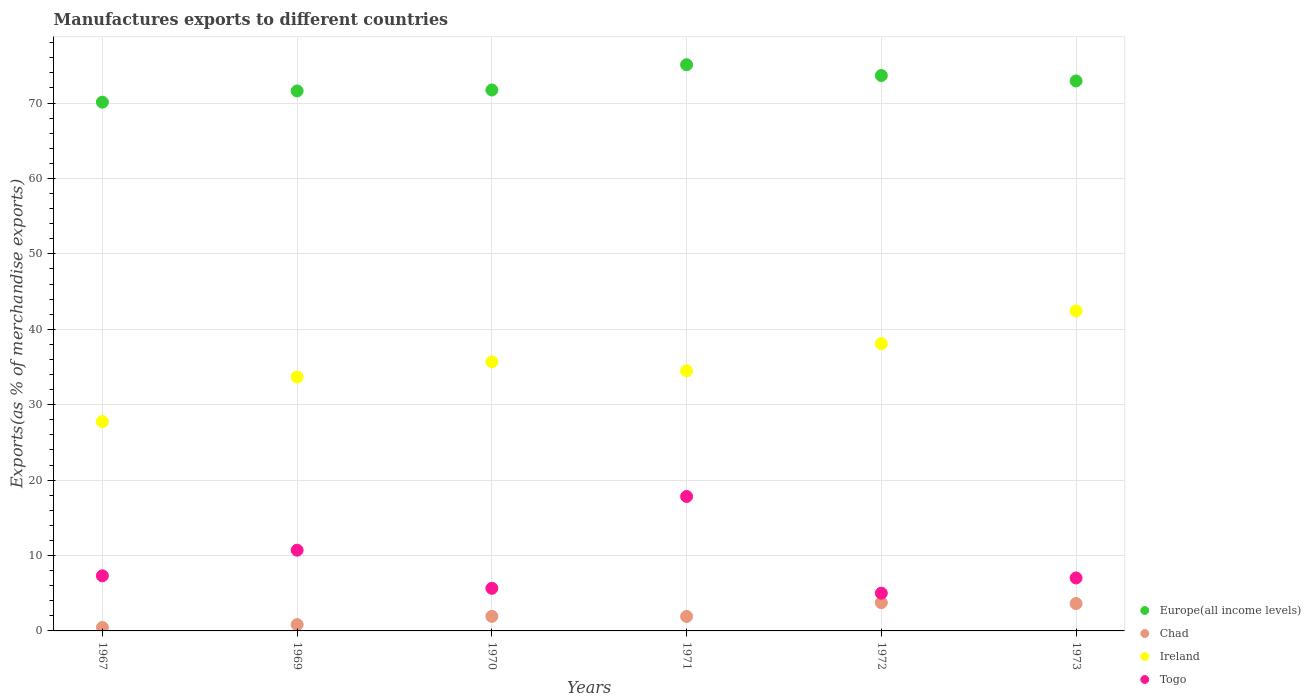Is the number of dotlines equal to the number of legend labels?
Your answer should be compact. Yes. What is the percentage of exports to different countries in Togo in 1973?
Provide a short and direct response. 7.02. Across all years, what is the maximum percentage of exports to different countries in Togo?
Your answer should be very brief. 17.83. Across all years, what is the minimum percentage of exports to different countries in Togo?
Ensure brevity in your answer.  5.01. In which year was the percentage of exports to different countries in Europe(all income levels) maximum?
Make the answer very short. 1971. What is the total percentage of exports to different countries in Ireland in the graph?
Your answer should be compact. 212.14. What is the difference between the percentage of exports to different countries in Chad in 1969 and that in 1972?
Your response must be concise. -2.91. What is the difference between the percentage of exports to different countries in Ireland in 1967 and the percentage of exports to different countries in Europe(all income levels) in 1970?
Your answer should be compact. -43.96. What is the average percentage of exports to different countries in Chad per year?
Keep it short and to the point. 2.09. In the year 1970, what is the difference between the percentage of exports to different countries in Europe(all income levels) and percentage of exports to different countries in Togo?
Keep it short and to the point. 66.08. What is the ratio of the percentage of exports to different countries in Europe(all income levels) in 1967 to that in 1972?
Your answer should be very brief. 0.95. What is the difference between the highest and the second highest percentage of exports to different countries in Ireland?
Keep it short and to the point. 4.33. What is the difference between the highest and the lowest percentage of exports to different countries in Europe(all income levels)?
Keep it short and to the point. 4.97. In how many years, is the percentage of exports to different countries in Togo greater than the average percentage of exports to different countries in Togo taken over all years?
Provide a succinct answer. 2. Is it the case that in every year, the sum of the percentage of exports to different countries in Togo and percentage of exports to different countries in Europe(all income levels)  is greater than the sum of percentage of exports to different countries in Chad and percentage of exports to different countries in Ireland?
Provide a short and direct response. Yes. Does the percentage of exports to different countries in Chad monotonically increase over the years?
Offer a very short reply. No. How many dotlines are there?
Offer a terse response. 4. What is the difference between two consecutive major ticks on the Y-axis?
Your answer should be compact. 10. Are the values on the major ticks of Y-axis written in scientific E-notation?
Make the answer very short. No. Where does the legend appear in the graph?
Provide a short and direct response. Bottom right. How many legend labels are there?
Make the answer very short. 4. What is the title of the graph?
Make the answer very short. Manufactures exports to different countries. What is the label or title of the Y-axis?
Make the answer very short. Exports(as % of merchandise exports). What is the Exports(as % of merchandise exports) in Europe(all income levels) in 1967?
Ensure brevity in your answer.  70.12. What is the Exports(as % of merchandise exports) in Chad in 1967?
Keep it short and to the point. 0.45. What is the Exports(as % of merchandise exports) of Ireland in 1967?
Offer a very short reply. 27.77. What is the Exports(as % of merchandise exports) in Togo in 1967?
Make the answer very short. 7.31. What is the Exports(as % of merchandise exports) of Europe(all income levels) in 1969?
Give a very brief answer. 71.6. What is the Exports(as % of merchandise exports) in Chad in 1969?
Ensure brevity in your answer.  0.84. What is the Exports(as % of merchandise exports) of Ireland in 1969?
Provide a succinct answer. 33.67. What is the Exports(as % of merchandise exports) of Togo in 1969?
Make the answer very short. 10.71. What is the Exports(as % of merchandise exports) in Europe(all income levels) in 1970?
Provide a succinct answer. 71.73. What is the Exports(as % of merchandise exports) in Chad in 1970?
Your answer should be compact. 1.93. What is the Exports(as % of merchandise exports) in Ireland in 1970?
Offer a terse response. 35.69. What is the Exports(as % of merchandise exports) in Togo in 1970?
Your response must be concise. 5.65. What is the Exports(as % of merchandise exports) of Europe(all income levels) in 1971?
Keep it short and to the point. 75.08. What is the Exports(as % of merchandise exports) of Chad in 1971?
Provide a short and direct response. 1.92. What is the Exports(as % of merchandise exports) in Ireland in 1971?
Offer a terse response. 34.49. What is the Exports(as % of merchandise exports) in Togo in 1971?
Provide a short and direct response. 17.83. What is the Exports(as % of merchandise exports) in Europe(all income levels) in 1972?
Provide a succinct answer. 73.65. What is the Exports(as % of merchandise exports) of Chad in 1972?
Make the answer very short. 3.75. What is the Exports(as % of merchandise exports) of Ireland in 1972?
Offer a terse response. 38.1. What is the Exports(as % of merchandise exports) in Togo in 1972?
Provide a short and direct response. 5.01. What is the Exports(as % of merchandise exports) of Europe(all income levels) in 1973?
Your response must be concise. 72.93. What is the Exports(as % of merchandise exports) in Chad in 1973?
Provide a succinct answer. 3.63. What is the Exports(as % of merchandise exports) of Ireland in 1973?
Make the answer very short. 42.43. What is the Exports(as % of merchandise exports) in Togo in 1973?
Keep it short and to the point. 7.02. Across all years, what is the maximum Exports(as % of merchandise exports) in Europe(all income levels)?
Provide a succinct answer. 75.08. Across all years, what is the maximum Exports(as % of merchandise exports) in Chad?
Offer a very short reply. 3.75. Across all years, what is the maximum Exports(as % of merchandise exports) of Ireland?
Your answer should be compact. 42.43. Across all years, what is the maximum Exports(as % of merchandise exports) in Togo?
Your answer should be compact. 17.83. Across all years, what is the minimum Exports(as % of merchandise exports) of Europe(all income levels)?
Your response must be concise. 70.12. Across all years, what is the minimum Exports(as % of merchandise exports) in Chad?
Keep it short and to the point. 0.45. Across all years, what is the minimum Exports(as % of merchandise exports) of Ireland?
Ensure brevity in your answer.  27.77. Across all years, what is the minimum Exports(as % of merchandise exports) of Togo?
Keep it short and to the point. 5.01. What is the total Exports(as % of merchandise exports) in Europe(all income levels) in the graph?
Provide a short and direct response. 435.11. What is the total Exports(as % of merchandise exports) of Chad in the graph?
Offer a very short reply. 12.52. What is the total Exports(as % of merchandise exports) in Ireland in the graph?
Keep it short and to the point. 212.14. What is the total Exports(as % of merchandise exports) of Togo in the graph?
Keep it short and to the point. 53.52. What is the difference between the Exports(as % of merchandise exports) of Europe(all income levels) in 1967 and that in 1969?
Make the answer very short. -1.49. What is the difference between the Exports(as % of merchandise exports) in Chad in 1967 and that in 1969?
Your response must be concise. -0.39. What is the difference between the Exports(as % of merchandise exports) in Ireland in 1967 and that in 1969?
Offer a terse response. -5.9. What is the difference between the Exports(as % of merchandise exports) of Togo in 1967 and that in 1969?
Your answer should be very brief. -3.4. What is the difference between the Exports(as % of merchandise exports) in Europe(all income levels) in 1967 and that in 1970?
Your answer should be compact. -1.61. What is the difference between the Exports(as % of merchandise exports) of Chad in 1967 and that in 1970?
Keep it short and to the point. -1.48. What is the difference between the Exports(as % of merchandise exports) of Ireland in 1967 and that in 1970?
Make the answer very short. -7.92. What is the difference between the Exports(as % of merchandise exports) in Togo in 1967 and that in 1970?
Provide a succinct answer. 1.66. What is the difference between the Exports(as % of merchandise exports) in Europe(all income levels) in 1967 and that in 1971?
Keep it short and to the point. -4.97. What is the difference between the Exports(as % of merchandise exports) of Chad in 1967 and that in 1971?
Keep it short and to the point. -1.47. What is the difference between the Exports(as % of merchandise exports) of Ireland in 1967 and that in 1971?
Keep it short and to the point. -6.72. What is the difference between the Exports(as % of merchandise exports) in Togo in 1967 and that in 1971?
Give a very brief answer. -10.52. What is the difference between the Exports(as % of merchandise exports) of Europe(all income levels) in 1967 and that in 1972?
Your answer should be compact. -3.54. What is the difference between the Exports(as % of merchandise exports) in Chad in 1967 and that in 1972?
Your answer should be compact. -3.29. What is the difference between the Exports(as % of merchandise exports) in Ireland in 1967 and that in 1972?
Provide a succinct answer. -10.33. What is the difference between the Exports(as % of merchandise exports) in Togo in 1967 and that in 1972?
Give a very brief answer. 2.3. What is the difference between the Exports(as % of merchandise exports) of Europe(all income levels) in 1967 and that in 1973?
Your response must be concise. -2.81. What is the difference between the Exports(as % of merchandise exports) of Chad in 1967 and that in 1973?
Offer a terse response. -3.18. What is the difference between the Exports(as % of merchandise exports) in Ireland in 1967 and that in 1973?
Your answer should be compact. -14.67. What is the difference between the Exports(as % of merchandise exports) in Togo in 1967 and that in 1973?
Make the answer very short. 0.29. What is the difference between the Exports(as % of merchandise exports) of Europe(all income levels) in 1969 and that in 1970?
Offer a very short reply. -0.13. What is the difference between the Exports(as % of merchandise exports) of Chad in 1969 and that in 1970?
Offer a very short reply. -1.09. What is the difference between the Exports(as % of merchandise exports) of Ireland in 1969 and that in 1970?
Give a very brief answer. -2.02. What is the difference between the Exports(as % of merchandise exports) of Togo in 1969 and that in 1970?
Offer a very short reply. 5.06. What is the difference between the Exports(as % of merchandise exports) in Europe(all income levels) in 1969 and that in 1971?
Your answer should be compact. -3.48. What is the difference between the Exports(as % of merchandise exports) in Chad in 1969 and that in 1971?
Provide a short and direct response. -1.08. What is the difference between the Exports(as % of merchandise exports) in Ireland in 1969 and that in 1971?
Provide a short and direct response. -0.82. What is the difference between the Exports(as % of merchandise exports) of Togo in 1969 and that in 1971?
Ensure brevity in your answer.  -7.12. What is the difference between the Exports(as % of merchandise exports) of Europe(all income levels) in 1969 and that in 1972?
Offer a very short reply. -2.05. What is the difference between the Exports(as % of merchandise exports) of Chad in 1969 and that in 1972?
Give a very brief answer. -2.91. What is the difference between the Exports(as % of merchandise exports) of Ireland in 1969 and that in 1972?
Your answer should be compact. -4.43. What is the difference between the Exports(as % of merchandise exports) of Togo in 1969 and that in 1972?
Make the answer very short. 5.7. What is the difference between the Exports(as % of merchandise exports) in Europe(all income levels) in 1969 and that in 1973?
Ensure brevity in your answer.  -1.33. What is the difference between the Exports(as % of merchandise exports) in Chad in 1969 and that in 1973?
Offer a very short reply. -2.79. What is the difference between the Exports(as % of merchandise exports) of Ireland in 1969 and that in 1973?
Offer a terse response. -8.77. What is the difference between the Exports(as % of merchandise exports) in Togo in 1969 and that in 1973?
Ensure brevity in your answer.  3.69. What is the difference between the Exports(as % of merchandise exports) in Europe(all income levels) in 1970 and that in 1971?
Offer a terse response. -3.35. What is the difference between the Exports(as % of merchandise exports) in Chad in 1970 and that in 1971?
Offer a terse response. 0.01. What is the difference between the Exports(as % of merchandise exports) of Ireland in 1970 and that in 1971?
Offer a terse response. 1.2. What is the difference between the Exports(as % of merchandise exports) of Togo in 1970 and that in 1971?
Ensure brevity in your answer.  -12.18. What is the difference between the Exports(as % of merchandise exports) of Europe(all income levels) in 1970 and that in 1972?
Give a very brief answer. -1.92. What is the difference between the Exports(as % of merchandise exports) in Chad in 1970 and that in 1972?
Provide a short and direct response. -1.82. What is the difference between the Exports(as % of merchandise exports) of Ireland in 1970 and that in 1972?
Make the answer very short. -2.41. What is the difference between the Exports(as % of merchandise exports) of Togo in 1970 and that in 1972?
Offer a terse response. 0.64. What is the difference between the Exports(as % of merchandise exports) of Europe(all income levels) in 1970 and that in 1973?
Give a very brief answer. -1.2. What is the difference between the Exports(as % of merchandise exports) in Chad in 1970 and that in 1973?
Provide a short and direct response. -1.7. What is the difference between the Exports(as % of merchandise exports) in Ireland in 1970 and that in 1973?
Make the answer very short. -6.74. What is the difference between the Exports(as % of merchandise exports) of Togo in 1970 and that in 1973?
Make the answer very short. -1.37. What is the difference between the Exports(as % of merchandise exports) in Europe(all income levels) in 1971 and that in 1972?
Offer a terse response. 1.43. What is the difference between the Exports(as % of merchandise exports) of Chad in 1971 and that in 1972?
Your response must be concise. -1.83. What is the difference between the Exports(as % of merchandise exports) in Ireland in 1971 and that in 1972?
Provide a succinct answer. -3.61. What is the difference between the Exports(as % of merchandise exports) of Togo in 1971 and that in 1972?
Ensure brevity in your answer.  12.82. What is the difference between the Exports(as % of merchandise exports) in Europe(all income levels) in 1971 and that in 1973?
Make the answer very short. 2.15. What is the difference between the Exports(as % of merchandise exports) of Chad in 1971 and that in 1973?
Ensure brevity in your answer.  -1.71. What is the difference between the Exports(as % of merchandise exports) in Ireland in 1971 and that in 1973?
Provide a short and direct response. -7.94. What is the difference between the Exports(as % of merchandise exports) of Togo in 1971 and that in 1973?
Your answer should be very brief. 10.81. What is the difference between the Exports(as % of merchandise exports) of Europe(all income levels) in 1972 and that in 1973?
Your answer should be very brief. 0.72. What is the difference between the Exports(as % of merchandise exports) in Chad in 1972 and that in 1973?
Your response must be concise. 0.11. What is the difference between the Exports(as % of merchandise exports) in Ireland in 1972 and that in 1973?
Make the answer very short. -4.33. What is the difference between the Exports(as % of merchandise exports) of Togo in 1972 and that in 1973?
Give a very brief answer. -2.01. What is the difference between the Exports(as % of merchandise exports) in Europe(all income levels) in 1967 and the Exports(as % of merchandise exports) in Chad in 1969?
Make the answer very short. 69.28. What is the difference between the Exports(as % of merchandise exports) of Europe(all income levels) in 1967 and the Exports(as % of merchandise exports) of Ireland in 1969?
Give a very brief answer. 36.45. What is the difference between the Exports(as % of merchandise exports) in Europe(all income levels) in 1967 and the Exports(as % of merchandise exports) in Togo in 1969?
Provide a succinct answer. 59.41. What is the difference between the Exports(as % of merchandise exports) of Chad in 1967 and the Exports(as % of merchandise exports) of Ireland in 1969?
Keep it short and to the point. -33.21. What is the difference between the Exports(as % of merchandise exports) in Chad in 1967 and the Exports(as % of merchandise exports) in Togo in 1969?
Provide a succinct answer. -10.25. What is the difference between the Exports(as % of merchandise exports) of Ireland in 1967 and the Exports(as % of merchandise exports) of Togo in 1969?
Your answer should be compact. 17.06. What is the difference between the Exports(as % of merchandise exports) of Europe(all income levels) in 1967 and the Exports(as % of merchandise exports) of Chad in 1970?
Ensure brevity in your answer.  68.18. What is the difference between the Exports(as % of merchandise exports) in Europe(all income levels) in 1967 and the Exports(as % of merchandise exports) in Ireland in 1970?
Your answer should be compact. 34.43. What is the difference between the Exports(as % of merchandise exports) in Europe(all income levels) in 1967 and the Exports(as % of merchandise exports) in Togo in 1970?
Your answer should be compact. 64.46. What is the difference between the Exports(as % of merchandise exports) in Chad in 1967 and the Exports(as % of merchandise exports) in Ireland in 1970?
Your answer should be very brief. -35.23. What is the difference between the Exports(as % of merchandise exports) of Chad in 1967 and the Exports(as % of merchandise exports) of Togo in 1970?
Your answer should be very brief. -5.2. What is the difference between the Exports(as % of merchandise exports) in Ireland in 1967 and the Exports(as % of merchandise exports) in Togo in 1970?
Make the answer very short. 22.11. What is the difference between the Exports(as % of merchandise exports) of Europe(all income levels) in 1967 and the Exports(as % of merchandise exports) of Chad in 1971?
Provide a succinct answer. 68.2. What is the difference between the Exports(as % of merchandise exports) in Europe(all income levels) in 1967 and the Exports(as % of merchandise exports) in Ireland in 1971?
Provide a succinct answer. 35.63. What is the difference between the Exports(as % of merchandise exports) in Europe(all income levels) in 1967 and the Exports(as % of merchandise exports) in Togo in 1971?
Make the answer very short. 52.29. What is the difference between the Exports(as % of merchandise exports) in Chad in 1967 and the Exports(as % of merchandise exports) in Ireland in 1971?
Provide a short and direct response. -34.04. What is the difference between the Exports(as % of merchandise exports) in Chad in 1967 and the Exports(as % of merchandise exports) in Togo in 1971?
Your answer should be very brief. -17.37. What is the difference between the Exports(as % of merchandise exports) of Ireland in 1967 and the Exports(as % of merchandise exports) of Togo in 1971?
Make the answer very short. 9.94. What is the difference between the Exports(as % of merchandise exports) of Europe(all income levels) in 1967 and the Exports(as % of merchandise exports) of Chad in 1972?
Your answer should be very brief. 66.37. What is the difference between the Exports(as % of merchandise exports) in Europe(all income levels) in 1967 and the Exports(as % of merchandise exports) in Ireland in 1972?
Offer a very short reply. 32.02. What is the difference between the Exports(as % of merchandise exports) in Europe(all income levels) in 1967 and the Exports(as % of merchandise exports) in Togo in 1972?
Give a very brief answer. 65.11. What is the difference between the Exports(as % of merchandise exports) of Chad in 1967 and the Exports(as % of merchandise exports) of Ireland in 1972?
Make the answer very short. -37.65. What is the difference between the Exports(as % of merchandise exports) of Chad in 1967 and the Exports(as % of merchandise exports) of Togo in 1972?
Ensure brevity in your answer.  -4.55. What is the difference between the Exports(as % of merchandise exports) in Ireland in 1967 and the Exports(as % of merchandise exports) in Togo in 1972?
Offer a very short reply. 22.76. What is the difference between the Exports(as % of merchandise exports) of Europe(all income levels) in 1967 and the Exports(as % of merchandise exports) of Chad in 1973?
Offer a very short reply. 66.48. What is the difference between the Exports(as % of merchandise exports) in Europe(all income levels) in 1967 and the Exports(as % of merchandise exports) in Ireland in 1973?
Your answer should be very brief. 27.68. What is the difference between the Exports(as % of merchandise exports) of Europe(all income levels) in 1967 and the Exports(as % of merchandise exports) of Togo in 1973?
Your answer should be compact. 63.09. What is the difference between the Exports(as % of merchandise exports) in Chad in 1967 and the Exports(as % of merchandise exports) in Ireland in 1973?
Your answer should be compact. -41.98. What is the difference between the Exports(as % of merchandise exports) in Chad in 1967 and the Exports(as % of merchandise exports) in Togo in 1973?
Offer a very short reply. -6.57. What is the difference between the Exports(as % of merchandise exports) of Ireland in 1967 and the Exports(as % of merchandise exports) of Togo in 1973?
Ensure brevity in your answer.  20.75. What is the difference between the Exports(as % of merchandise exports) in Europe(all income levels) in 1969 and the Exports(as % of merchandise exports) in Chad in 1970?
Your answer should be very brief. 69.67. What is the difference between the Exports(as % of merchandise exports) of Europe(all income levels) in 1969 and the Exports(as % of merchandise exports) of Ireland in 1970?
Ensure brevity in your answer.  35.91. What is the difference between the Exports(as % of merchandise exports) in Europe(all income levels) in 1969 and the Exports(as % of merchandise exports) in Togo in 1970?
Give a very brief answer. 65.95. What is the difference between the Exports(as % of merchandise exports) in Chad in 1969 and the Exports(as % of merchandise exports) in Ireland in 1970?
Make the answer very short. -34.85. What is the difference between the Exports(as % of merchandise exports) in Chad in 1969 and the Exports(as % of merchandise exports) in Togo in 1970?
Give a very brief answer. -4.81. What is the difference between the Exports(as % of merchandise exports) of Ireland in 1969 and the Exports(as % of merchandise exports) of Togo in 1970?
Offer a terse response. 28.02. What is the difference between the Exports(as % of merchandise exports) of Europe(all income levels) in 1969 and the Exports(as % of merchandise exports) of Chad in 1971?
Make the answer very short. 69.68. What is the difference between the Exports(as % of merchandise exports) in Europe(all income levels) in 1969 and the Exports(as % of merchandise exports) in Ireland in 1971?
Your answer should be very brief. 37.11. What is the difference between the Exports(as % of merchandise exports) of Europe(all income levels) in 1969 and the Exports(as % of merchandise exports) of Togo in 1971?
Your answer should be very brief. 53.77. What is the difference between the Exports(as % of merchandise exports) of Chad in 1969 and the Exports(as % of merchandise exports) of Ireland in 1971?
Give a very brief answer. -33.65. What is the difference between the Exports(as % of merchandise exports) in Chad in 1969 and the Exports(as % of merchandise exports) in Togo in 1971?
Your answer should be compact. -16.99. What is the difference between the Exports(as % of merchandise exports) in Ireland in 1969 and the Exports(as % of merchandise exports) in Togo in 1971?
Provide a succinct answer. 15.84. What is the difference between the Exports(as % of merchandise exports) of Europe(all income levels) in 1969 and the Exports(as % of merchandise exports) of Chad in 1972?
Make the answer very short. 67.86. What is the difference between the Exports(as % of merchandise exports) in Europe(all income levels) in 1969 and the Exports(as % of merchandise exports) in Ireland in 1972?
Offer a terse response. 33.5. What is the difference between the Exports(as % of merchandise exports) of Europe(all income levels) in 1969 and the Exports(as % of merchandise exports) of Togo in 1972?
Make the answer very short. 66.6. What is the difference between the Exports(as % of merchandise exports) of Chad in 1969 and the Exports(as % of merchandise exports) of Ireland in 1972?
Keep it short and to the point. -37.26. What is the difference between the Exports(as % of merchandise exports) of Chad in 1969 and the Exports(as % of merchandise exports) of Togo in 1972?
Give a very brief answer. -4.17. What is the difference between the Exports(as % of merchandise exports) in Ireland in 1969 and the Exports(as % of merchandise exports) in Togo in 1972?
Provide a short and direct response. 28.66. What is the difference between the Exports(as % of merchandise exports) in Europe(all income levels) in 1969 and the Exports(as % of merchandise exports) in Chad in 1973?
Ensure brevity in your answer.  67.97. What is the difference between the Exports(as % of merchandise exports) in Europe(all income levels) in 1969 and the Exports(as % of merchandise exports) in Ireland in 1973?
Your response must be concise. 29.17. What is the difference between the Exports(as % of merchandise exports) in Europe(all income levels) in 1969 and the Exports(as % of merchandise exports) in Togo in 1973?
Keep it short and to the point. 64.58. What is the difference between the Exports(as % of merchandise exports) in Chad in 1969 and the Exports(as % of merchandise exports) in Ireland in 1973?
Provide a succinct answer. -41.59. What is the difference between the Exports(as % of merchandise exports) of Chad in 1969 and the Exports(as % of merchandise exports) of Togo in 1973?
Provide a short and direct response. -6.18. What is the difference between the Exports(as % of merchandise exports) in Ireland in 1969 and the Exports(as % of merchandise exports) in Togo in 1973?
Provide a succinct answer. 26.65. What is the difference between the Exports(as % of merchandise exports) in Europe(all income levels) in 1970 and the Exports(as % of merchandise exports) in Chad in 1971?
Provide a short and direct response. 69.81. What is the difference between the Exports(as % of merchandise exports) in Europe(all income levels) in 1970 and the Exports(as % of merchandise exports) in Ireland in 1971?
Provide a short and direct response. 37.24. What is the difference between the Exports(as % of merchandise exports) in Europe(all income levels) in 1970 and the Exports(as % of merchandise exports) in Togo in 1971?
Make the answer very short. 53.9. What is the difference between the Exports(as % of merchandise exports) in Chad in 1970 and the Exports(as % of merchandise exports) in Ireland in 1971?
Your response must be concise. -32.56. What is the difference between the Exports(as % of merchandise exports) in Chad in 1970 and the Exports(as % of merchandise exports) in Togo in 1971?
Ensure brevity in your answer.  -15.9. What is the difference between the Exports(as % of merchandise exports) of Ireland in 1970 and the Exports(as % of merchandise exports) of Togo in 1971?
Offer a terse response. 17.86. What is the difference between the Exports(as % of merchandise exports) in Europe(all income levels) in 1970 and the Exports(as % of merchandise exports) in Chad in 1972?
Your answer should be compact. 67.98. What is the difference between the Exports(as % of merchandise exports) of Europe(all income levels) in 1970 and the Exports(as % of merchandise exports) of Ireland in 1972?
Give a very brief answer. 33.63. What is the difference between the Exports(as % of merchandise exports) of Europe(all income levels) in 1970 and the Exports(as % of merchandise exports) of Togo in 1972?
Give a very brief answer. 66.72. What is the difference between the Exports(as % of merchandise exports) of Chad in 1970 and the Exports(as % of merchandise exports) of Ireland in 1972?
Provide a short and direct response. -36.17. What is the difference between the Exports(as % of merchandise exports) of Chad in 1970 and the Exports(as % of merchandise exports) of Togo in 1972?
Your answer should be compact. -3.08. What is the difference between the Exports(as % of merchandise exports) in Ireland in 1970 and the Exports(as % of merchandise exports) in Togo in 1972?
Your response must be concise. 30.68. What is the difference between the Exports(as % of merchandise exports) in Europe(all income levels) in 1970 and the Exports(as % of merchandise exports) in Chad in 1973?
Provide a short and direct response. 68.1. What is the difference between the Exports(as % of merchandise exports) of Europe(all income levels) in 1970 and the Exports(as % of merchandise exports) of Ireland in 1973?
Your answer should be very brief. 29.29. What is the difference between the Exports(as % of merchandise exports) in Europe(all income levels) in 1970 and the Exports(as % of merchandise exports) in Togo in 1973?
Give a very brief answer. 64.71. What is the difference between the Exports(as % of merchandise exports) in Chad in 1970 and the Exports(as % of merchandise exports) in Ireland in 1973?
Make the answer very short. -40.5. What is the difference between the Exports(as % of merchandise exports) in Chad in 1970 and the Exports(as % of merchandise exports) in Togo in 1973?
Provide a succinct answer. -5.09. What is the difference between the Exports(as % of merchandise exports) of Ireland in 1970 and the Exports(as % of merchandise exports) of Togo in 1973?
Ensure brevity in your answer.  28.67. What is the difference between the Exports(as % of merchandise exports) in Europe(all income levels) in 1971 and the Exports(as % of merchandise exports) in Chad in 1972?
Make the answer very short. 71.33. What is the difference between the Exports(as % of merchandise exports) of Europe(all income levels) in 1971 and the Exports(as % of merchandise exports) of Ireland in 1972?
Offer a very short reply. 36.98. What is the difference between the Exports(as % of merchandise exports) in Europe(all income levels) in 1971 and the Exports(as % of merchandise exports) in Togo in 1972?
Offer a very short reply. 70.08. What is the difference between the Exports(as % of merchandise exports) of Chad in 1971 and the Exports(as % of merchandise exports) of Ireland in 1972?
Make the answer very short. -36.18. What is the difference between the Exports(as % of merchandise exports) in Chad in 1971 and the Exports(as % of merchandise exports) in Togo in 1972?
Make the answer very short. -3.09. What is the difference between the Exports(as % of merchandise exports) of Ireland in 1971 and the Exports(as % of merchandise exports) of Togo in 1972?
Keep it short and to the point. 29.48. What is the difference between the Exports(as % of merchandise exports) of Europe(all income levels) in 1971 and the Exports(as % of merchandise exports) of Chad in 1973?
Your answer should be compact. 71.45. What is the difference between the Exports(as % of merchandise exports) in Europe(all income levels) in 1971 and the Exports(as % of merchandise exports) in Ireland in 1973?
Ensure brevity in your answer.  32.65. What is the difference between the Exports(as % of merchandise exports) of Europe(all income levels) in 1971 and the Exports(as % of merchandise exports) of Togo in 1973?
Your response must be concise. 68.06. What is the difference between the Exports(as % of merchandise exports) of Chad in 1971 and the Exports(as % of merchandise exports) of Ireland in 1973?
Ensure brevity in your answer.  -40.51. What is the difference between the Exports(as % of merchandise exports) in Chad in 1971 and the Exports(as % of merchandise exports) in Togo in 1973?
Offer a very short reply. -5.1. What is the difference between the Exports(as % of merchandise exports) of Ireland in 1971 and the Exports(as % of merchandise exports) of Togo in 1973?
Provide a short and direct response. 27.47. What is the difference between the Exports(as % of merchandise exports) in Europe(all income levels) in 1972 and the Exports(as % of merchandise exports) in Chad in 1973?
Provide a succinct answer. 70.02. What is the difference between the Exports(as % of merchandise exports) of Europe(all income levels) in 1972 and the Exports(as % of merchandise exports) of Ireland in 1973?
Your answer should be compact. 31.22. What is the difference between the Exports(as % of merchandise exports) in Europe(all income levels) in 1972 and the Exports(as % of merchandise exports) in Togo in 1973?
Keep it short and to the point. 66.63. What is the difference between the Exports(as % of merchandise exports) in Chad in 1972 and the Exports(as % of merchandise exports) in Ireland in 1973?
Your answer should be compact. -38.69. What is the difference between the Exports(as % of merchandise exports) in Chad in 1972 and the Exports(as % of merchandise exports) in Togo in 1973?
Give a very brief answer. -3.27. What is the difference between the Exports(as % of merchandise exports) in Ireland in 1972 and the Exports(as % of merchandise exports) in Togo in 1973?
Keep it short and to the point. 31.08. What is the average Exports(as % of merchandise exports) in Europe(all income levels) per year?
Offer a terse response. 72.52. What is the average Exports(as % of merchandise exports) of Chad per year?
Offer a terse response. 2.09. What is the average Exports(as % of merchandise exports) of Ireland per year?
Your answer should be very brief. 35.36. What is the average Exports(as % of merchandise exports) in Togo per year?
Provide a short and direct response. 8.92. In the year 1967, what is the difference between the Exports(as % of merchandise exports) of Europe(all income levels) and Exports(as % of merchandise exports) of Chad?
Your answer should be compact. 69.66. In the year 1967, what is the difference between the Exports(as % of merchandise exports) in Europe(all income levels) and Exports(as % of merchandise exports) in Ireland?
Give a very brief answer. 42.35. In the year 1967, what is the difference between the Exports(as % of merchandise exports) of Europe(all income levels) and Exports(as % of merchandise exports) of Togo?
Offer a terse response. 62.81. In the year 1967, what is the difference between the Exports(as % of merchandise exports) in Chad and Exports(as % of merchandise exports) in Ireland?
Provide a succinct answer. -27.31. In the year 1967, what is the difference between the Exports(as % of merchandise exports) in Chad and Exports(as % of merchandise exports) in Togo?
Make the answer very short. -6.85. In the year 1967, what is the difference between the Exports(as % of merchandise exports) of Ireland and Exports(as % of merchandise exports) of Togo?
Your answer should be very brief. 20.46. In the year 1969, what is the difference between the Exports(as % of merchandise exports) of Europe(all income levels) and Exports(as % of merchandise exports) of Chad?
Give a very brief answer. 70.76. In the year 1969, what is the difference between the Exports(as % of merchandise exports) of Europe(all income levels) and Exports(as % of merchandise exports) of Ireland?
Keep it short and to the point. 37.93. In the year 1969, what is the difference between the Exports(as % of merchandise exports) in Europe(all income levels) and Exports(as % of merchandise exports) in Togo?
Ensure brevity in your answer.  60.9. In the year 1969, what is the difference between the Exports(as % of merchandise exports) in Chad and Exports(as % of merchandise exports) in Ireland?
Your response must be concise. -32.83. In the year 1969, what is the difference between the Exports(as % of merchandise exports) of Chad and Exports(as % of merchandise exports) of Togo?
Ensure brevity in your answer.  -9.87. In the year 1969, what is the difference between the Exports(as % of merchandise exports) in Ireland and Exports(as % of merchandise exports) in Togo?
Provide a succinct answer. 22.96. In the year 1970, what is the difference between the Exports(as % of merchandise exports) of Europe(all income levels) and Exports(as % of merchandise exports) of Chad?
Your response must be concise. 69.8. In the year 1970, what is the difference between the Exports(as % of merchandise exports) in Europe(all income levels) and Exports(as % of merchandise exports) in Ireland?
Give a very brief answer. 36.04. In the year 1970, what is the difference between the Exports(as % of merchandise exports) in Europe(all income levels) and Exports(as % of merchandise exports) in Togo?
Make the answer very short. 66.08. In the year 1970, what is the difference between the Exports(as % of merchandise exports) in Chad and Exports(as % of merchandise exports) in Ireland?
Your answer should be very brief. -33.76. In the year 1970, what is the difference between the Exports(as % of merchandise exports) of Chad and Exports(as % of merchandise exports) of Togo?
Keep it short and to the point. -3.72. In the year 1970, what is the difference between the Exports(as % of merchandise exports) in Ireland and Exports(as % of merchandise exports) in Togo?
Make the answer very short. 30.04. In the year 1971, what is the difference between the Exports(as % of merchandise exports) in Europe(all income levels) and Exports(as % of merchandise exports) in Chad?
Your answer should be very brief. 73.16. In the year 1971, what is the difference between the Exports(as % of merchandise exports) in Europe(all income levels) and Exports(as % of merchandise exports) in Ireland?
Provide a short and direct response. 40.59. In the year 1971, what is the difference between the Exports(as % of merchandise exports) of Europe(all income levels) and Exports(as % of merchandise exports) of Togo?
Ensure brevity in your answer.  57.25. In the year 1971, what is the difference between the Exports(as % of merchandise exports) of Chad and Exports(as % of merchandise exports) of Ireland?
Ensure brevity in your answer.  -32.57. In the year 1971, what is the difference between the Exports(as % of merchandise exports) of Chad and Exports(as % of merchandise exports) of Togo?
Ensure brevity in your answer.  -15.91. In the year 1971, what is the difference between the Exports(as % of merchandise exports) in Ireland and Exports(as % of merchandise exports) in Togo?
Provide a succinct answer. 16.66. In the year 1972, what is the difference between the Exports(as % of merchandise exports) of Europe(all income levels) and Exports(as % of merchandise exports) of Chad?
Make the answer very short. 69.9. In the year 1972, what is the difference between the Exports(as % of merchandise exports) of Europe(all income levels) and Exports(as % of merchandise exports) of Ireland?
Your answer should be very brief. 35.55. In the year 1972, what is the difference between the Exports(as % of merchandise exports) of Europe(all income levels) and Exports(as % of merchandise exports) of Togo?
Make the answer very short. 68.64. In the year 1972, what is the difference between the Exports(as % of merchandise exports) of Chad and Exports(as % of merchandise exports) of Ireland?
Provide a short and direct response. -34.35. In the year 1972, what is the difference between the Exports(as % of merchandise exports) in Chad and Exports(as % of merchandise exports) in Togo?
Your answer should be compact. -1.26. In the year 1972, what is the difference between the Exports(as % of merchandise exports) of Ireland and Exports(as % of merchandise exports) of Togo?
Provide a short and direct response. 33.09. In the year 1973, what is the difference between the Exports(as % of merchandise exports) of Europe(all income levels) and Exports(as % of merchandise exports) of Chad?
Provide a short and direct response. 69.3. In the year 1973, what is the difference between the Exports(as % of merchandise exports) in Europe(all income levels) and Exports(as % of merchandise exports) in Ireland?
Make the answer very short. 30.5. In the year 1973, what is the difference between the Exports(as % of merchandise exports) in Europe(all income levels) and Exports(as % of merchandise exports) in Togo?
Make the answer very short. 65.91. In the year 1973, what is the difference between the Exports(as % of merchandise exports) of Chad and Exports(as % of merchandise exports) of Ireland?
Keep it short and to the point. -38.8. In the year 1973, what is the difference between the Exports(as % of merchandise exports) in Chad and Exports(as % of merchandise exports) in Togo?
Ensure brevity in your answer.  -3.39. In the year 1973, what is the difference between the Exports(as % of merchandise exports) of Ireland and Exports(as % of merchandise exports) of Togo?
Provide a short and direct response. 35.41. What is the ratio of the Exports(as % of merchandise exports) of Europe(all income levels) in 1967 to that in 1969?
Give a very brief answer. 0.98. What is the ratio of the Exports(as % of merchandise exports) in Chad in 1967 to that in 1969?
Give a very brief answer. 0.54. What is the ratio of the Exports(as % of merchandise exports) in Ireland in 1967 to that in 1969?
Provide a short and direct response. 0.82. What is the ratio of the Exports(as % of merchandise exports) of Togo in 1967 to that in 1969?
Your answer should be very brief. 0.68. What is the ratio of the Exports(as % of merchandise exports) in Europe(all income levels) in 1967 to that in 1970?
Offer a terse response. 0.98. What is the ratio of the Exports(as % of merchandise exports) in Chad in 1967 to that in 1970?
Your answer should be very brief. 0.23. What is the ratio of the Exports(as % of merchandise exports) of Ireland in 1967 to that in 1970?
Keep it short and to the point. 0.78. What is the ratio of the Exports(as % of merchandise exports) of Togo in 1967 to that in 1970?
Provide a short and direct response. 1.29. What is the ratio of the Exports(as % of merchandise exports) in Europe(all income levels) in 1967 to that in 1971?
Keep it short and to the point. 0.93. What is the ratio of the Exports(as % of merchandise exports) in Chad in 1967 to that in 1971?
Make the answer very short. 0.24. What is the ratio of the Exports(as % of merchandise exports) in Ireland in 1967 to that in 1971?
Offer a very short reply. 0.81. What is the ratio of the Exports(as % of merchandise exports) of Togo in 1967 to that in 1971?
Make the answer very short. 0.41. What is the ratio of the Exports(as % of merchandise exports) in Chad in 1967 to that in 1972?
Give a very brief answer. 0.12. What is the ratio of the Exports(as % of merchandise exports) in Ireland in 1967 to that in 1972?
Offer a terse response. 0.73. What is the ratio of the Exports(as % of merchandise exports) in Togo in 1967 to that in 1972?
Make the answer very short. 1.46. What is the ratio of the Exports(as % of merchandise exports) of Europe(all income levels) in 1967 to that in 1973?
Offer a terse response. 0.96. What is the ratio of the Exports(as % of merchandise exports) of Chad in 1967 to that in 1973?
Give a very brief answer. 0.12. What is the ratio of the Exports(as % of merchandise exports) in Ireland in 1967 to that in 1973?
Keep it short and to the point. 0.65. What is the ratio of the Exports(as % of merchandise exports) in Togo in 1967 to that in 1973?
Your answer should be very brief. 1.04. What is the ratio of the Exports(as % of merchandise exports) in Chad in 1969 to that in 1970?
Provide a short and direct response. 0.43. What is the ratio of the Exports(as % of merchandise exports) of Ireland in 1969 to that in 1970?
Ensure brevity in your answer.  0.94. What is the ratio of the Exports(as % of merchandise exports) in Togo in 1969 to that in 1970?
Offer a terse response. 1.89. What is the ratio of the Exports(as % of merchandise exports) of Europe(all income levels) in 1969 to that in 1971?
Provide a succinct answer. 0.95. What is the ratio of the Exports(as % of merchandise exports) in Chad in 1969 to that in 1971?
Give a very brief answer. 0.44. What is the ratio of the Exports(as % of merchandise exports) of Ireland in 1969 to that in 1971?
Your response must be concise. 0.98. What is the ratio of the Exports(as % of merchandise exports) of Togo in 1969 to that in 1971?
Ensure brevity in your answer.  0.6. What is the ratio of the Exports(as % of merchandise exports) of Europe(all income levels) in 1969 to that in 1972?
Give a very brief answer. 0.97. What is the ratio of the Exports(as % of merchandise exports) in Chad in 1969 to that in 1972?
Give a very brief answer. 0.22. What is the ratio of the Exports(as % of merchandise exports) in Ireland in 1969 to that in 1972?
Your response must be concise. 0.88. What is the ratio of the Exports(as % of merchandise exports) in Togo in 1969 to that in 1972?
Your answer should be very brief. 2.14. What is the ratio of the Exports(as % of merchandise exports) in Europe(all income levels) in 1969 to that in 1973?
Offer a very short reply. 0.98. What is the ratio of the Exports(as % of merchandise exports) in Chad in 1969 to that in 1973?
Provide a short and direct response. 0.23. What is the ratio of the Exports(as % of merchandise exports) in Ireland in 1969 to that in 1973?
Provide a succinct answer. 0.79. What is the ratio of the Exports(as % of merchandise exports) of Togo in 1969 to that in 1973?
Make the answer very short. 1.52. What is the ratio of the Exports(as % of merchandise exports) in Europe(all income levels) in 1970 to that in 1971?
Offer a very short reply. 0.96. What is the ratio of the Exports(as % of merchandise exports) in Ireland in 1970 to that in 1971?
Offer a terse response. 1.03. What is the ratio of the Exports(as % of merchandise exports) of Togo in 1970 to that in 1971?
Make the answer very short. 0.32. What is the ratio of the Exports(as % of merchandise exports) of Europe(all income levels) in 1970 to that in 1972?
Give a very brief answer. 0.97. What is the ratio of the Exports(as % of merchandise exports) in Chad in 1970 to that in 1972?
Your answer should be compact. 0.52. What is the ratio of the Exports(as % of merchandise exports) of Ireland in 1970 to that in 1972?
Ensure brevity in your answer.  0.94. What is the ratio of the Exports(as % of merchandise exports) in Togo in 1970 to that in 1972?
Give a very brief answer. 1.13. What is the ratio of the Exports(as % of merchandise exports) in Europe(all income levels) in 1970 to that in 1973?
Provide a short and direct response. 0.98. What is the ratio of the Exports(as % of merchandise exports) in Chad in 1970 to that in 1973?
Ensure brevity in your answer.  0.53. What is the ratio of the Exports(as % of merchandise exports) of Ireland in 1970 to that in 1973?
Your response must be concise. 0.84. What is the ratio of the Exports(as % of merchandise exports) of Togo in 1970 to that in 1973?
Your answer should be compact. 0.8. What is the ratio of the Exports(as % of merchandise exports) in Europe(all income levels) in 1971 to that in 1972?
Your answer should be very brief. 1.02. What is the ratio of the Exports(as % of merchandise exports) in Chad in 1971 to that in 1972?
Your response must be concise. 0.51. What is the ratio of the Exports(as % of merchandise exports) of Ireland in 1971 to that in 1972?
Provide a short and direct response. 0.91. What is the ratio of the Exports(as % of merchandise exports) of Togo in 1971 to that in 1972?
Offer a very short reply. 3.56. What is the ratio of the Exports(as % of merchandise exports) of Europe(all income levels) in 1971 to that in 1973?
Ensure brevity in your answer.  1.03. What is the ratio of the Exports(as % of merchandise exports) in Chad in 1971 to that in 1973?
Give a very brief answer. 0.53. What is the ratio of the Exports(as % of merchandise exports) of Ireland in 1971 to that in 1973?
Offer a terse response. 0.81. What is the ratio of the Exports(as % of merchandise exports) in Togo in 1971 to that in 1973?
Ensure brevity in your answer.  2.54. What is the ratio of the Exports(as % of merchandise exports) in Europe(all income levels) in 1972 to that in 1973?
Provide a succinct answer. 1.01. What is the ratio of the Exports(as % of merchandise exports) in Chad in 1972 to that in 1973?
Keep it short and to the point. 1.03. What is the ratio of the Exports(as % of merchandise exports) in Ireland in 1972 to that in 1973?
Your answer should be very brief. 0.9. What is the ratio of the Exports(as % of merchandise exports) of Togo in 1972 to that in 1973?
Provide a succinct answer. 0.71. What is the difference between the highest and the second highest Exports(as % of merchandise exports) in Europe(all income levels)?
Ensure brevity in your answer.  1.43. What is the difference between the highest and the second highest Exports(as % of merchandise exports) in Chad?
Offer a terse response. 0.11. What is the difference between the highest and the second highest Exports(as % of merchandise exports) in Ireland?
Your response must be concise. 4.33. What is the difference between the highest and the second highest Exports(as % of merchandise exports) of Togo?
Ensure brevity in your answer.  7.12. What is the difference between the highest and the lowest Exports(as % of merchandise exports) of Europe(all income levels)?
Provide a short and direct response. 4.97. What is the difference between the highest and the lowest Exports(as % of merchandise exports) in Chad?
Your response must be concise. 3.29. What is the difference between the highest and the lowest Exports(as % of merchandise exports) of Ireland?
Your response must be concise. 14.67. What is the difference between the highest and the lowest Exports(as % of merchandise exports) in Togo?
Provide a succinct answer. 12.82. 